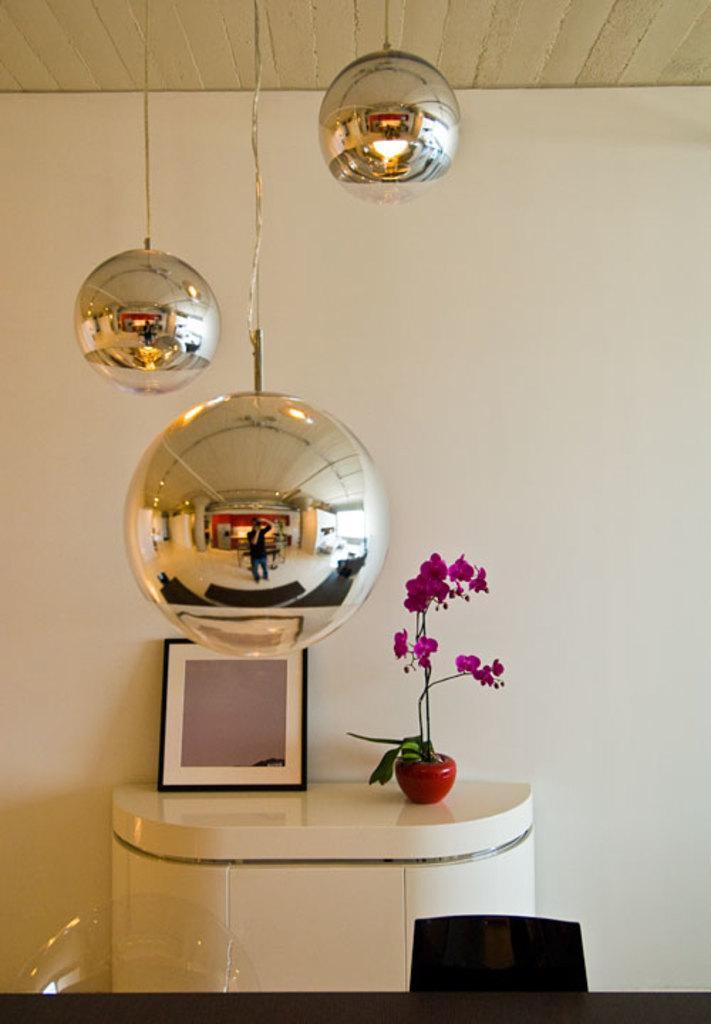Could you give a brief overview of what you see in this image? In the foreground of this image, on the bottom, it seems like a table and the chair. In the background, on the wall desk, there is a frame and a flower vase. On the top, there are few balls hanging to the ceiling. 